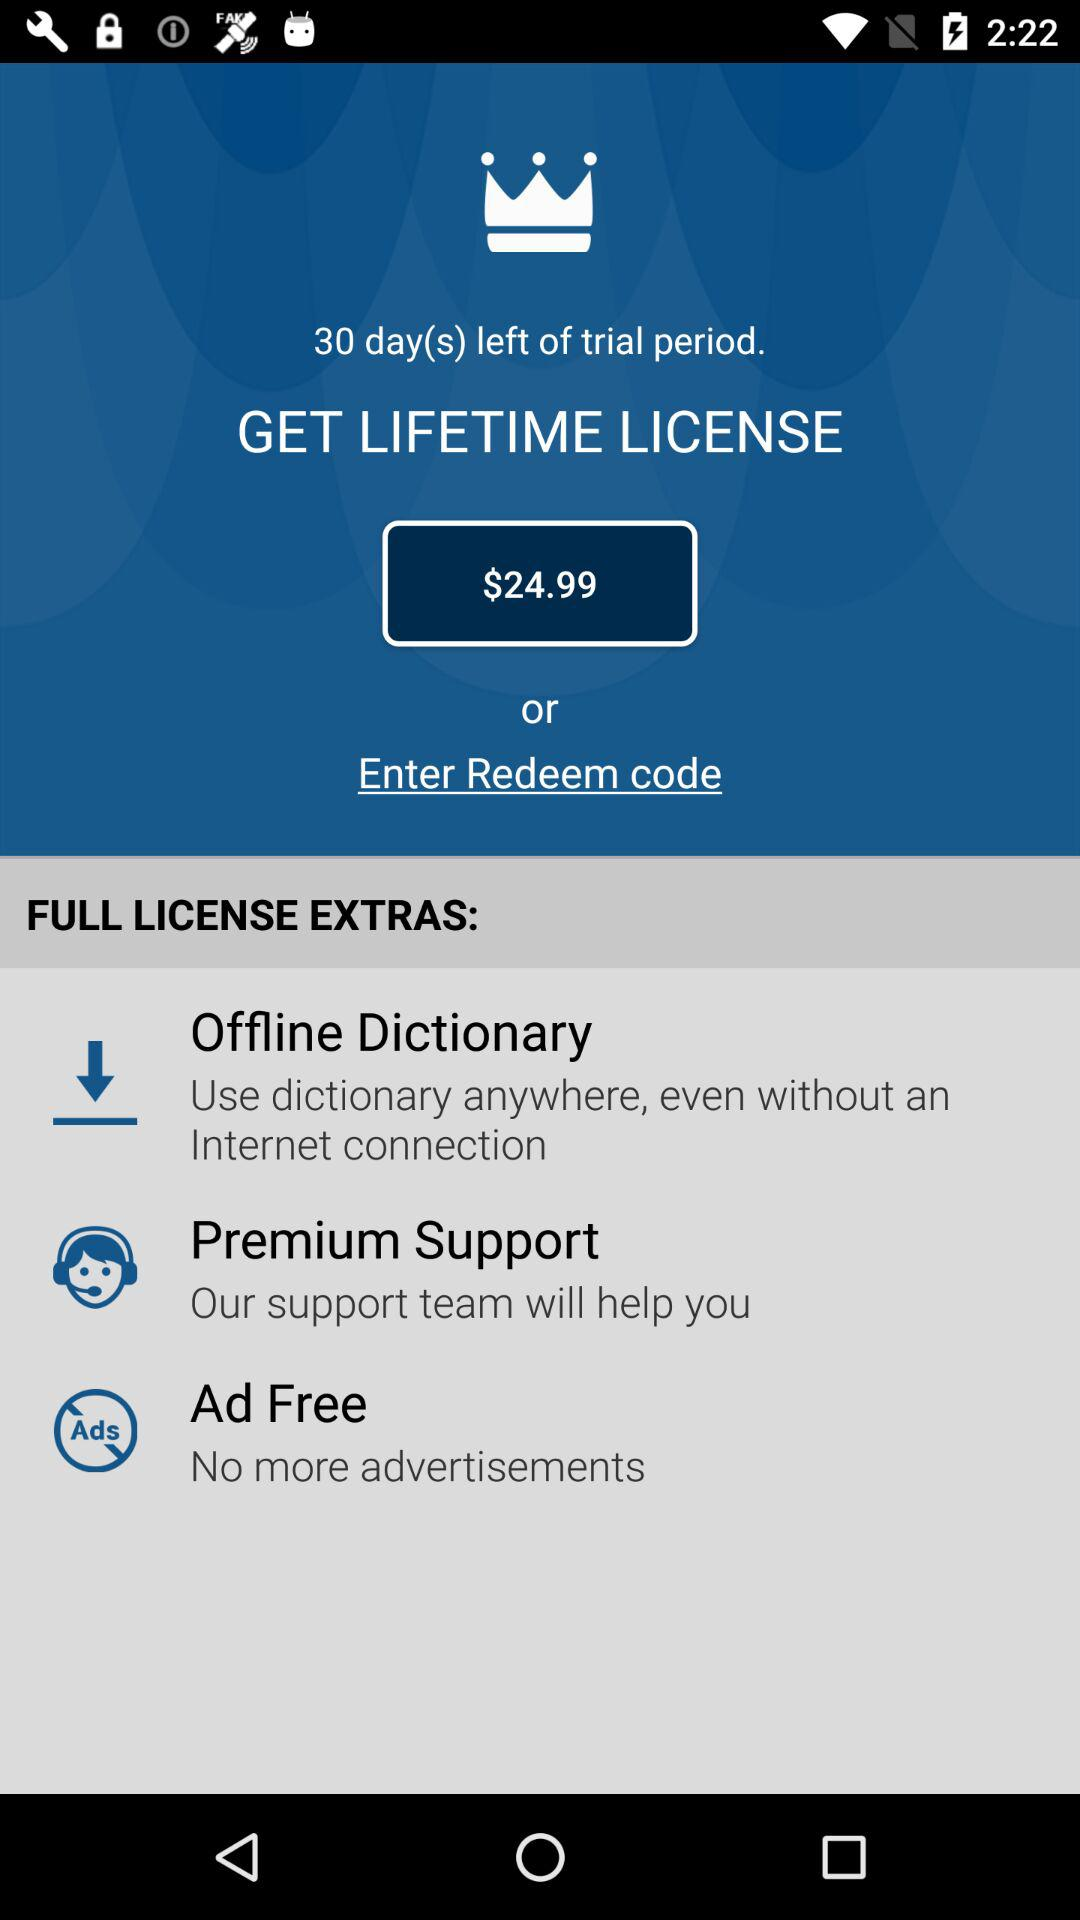How many numbers are in the redeem code?
When the provided information is insufficient, respond with <no answer>. <no answer> 